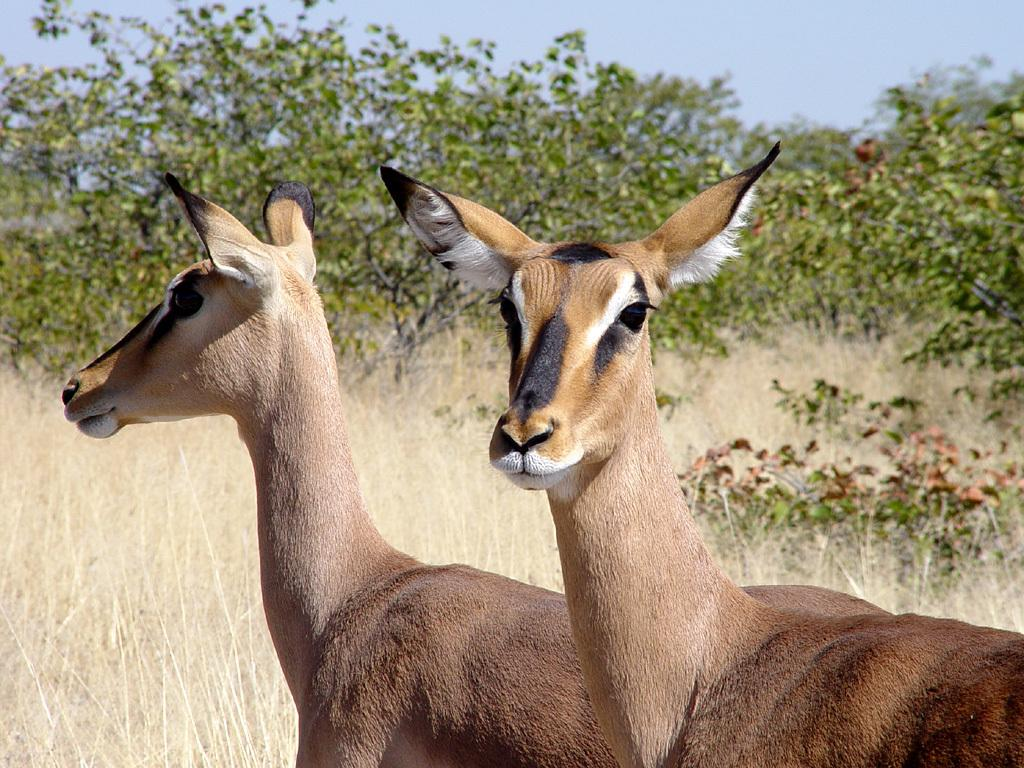What types of animals are in the foreground of the image? There are two animals in the foreground of the image. What can be seen in the background of the image? There are trees and grass in the background of the image. What type of quince is being used as a table in the image? There is no quince or table present in the image. What is being served for breakfast in the image? There is no mention of breakfast or any food items in the image. 